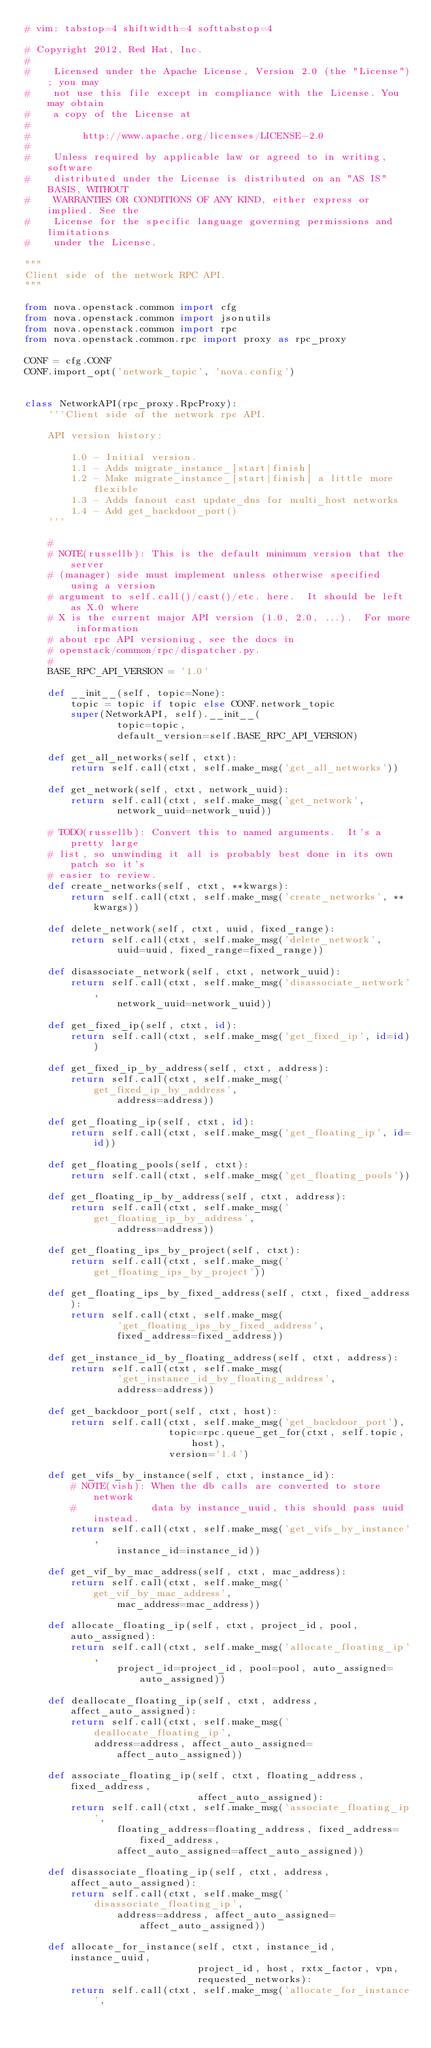Convert code to text. <code><loc_0><loc_0><loc_500><loc_500><_Python_># vim: tabstop=4 shiftwidth=4 softtabstop=4

# Copyright 2012, Red Hat, Inc.
#
#    Licensed under the Apache License, Version 2.0 (the "License"); you may
#    not use this file except in compliance with the License. You may obtain
#    a copy of the License at
#
#         http://www.apache.org/licenses/LICENSE-2.0
#
#    Unless required by applicable law or agreed to in writing, software
#    distributed under the License is distributed on an "AS IS" BASIS, WITHOUT
#    WARRANTIES OR CONDITIONS OF ANY KIND, either express or implied. See the
#    License for the specific language governing permissions and limitations
#    under the License.

"""
Client side of the network RPC API.
"""

from nova.openstack.common import cfg
from nova.openstack.common import jsonutils
from nova.openstack.common import rpc
from nova.openstack.common.rpc import proxy as rpc_proxy

CONF = cfg.CONF
CONF.import_opt('network_topic', 'nova.config')


class NetworkAPI(rpc_proxy.RpcProxy):
    '''Client side of the network rpc API.

    API version history:

        1.0 - Initial version.
        1.1 - Adds migrate_instance_[start|finish]
        1.2 - Make migrate_instance_[start|finish] a little more flexible
        1.3 - Adds fanout cast update_dns for multi_host networks
        1.4 - Add get_backdoor_port()
    '''

    #
    # NOTE(russellb): This is the default minimum version that the server
    # (manager) side must implement unless otherwise specified using a version
    # argument to self.call()/cast()/etc. here.  It should be left as X.0 where
    # X is the current major API version (1.0, 2.0, ...).  For more information
    # about rpc API versioning, see the docs in
    # openstack/common/rpc/dispatcher.py.
    #
    BASE_RPC_API_VERSION = '1.0'

    def __init__(self, topic=None):
        topic = topic if topic else CONF.network_topic
        super(NetworkAPI, self).__init__(
                topic=topic,
                default_version=self.BASE_RPC_API_VERSION)

    def get_all_networks(self, ctxt):
        return self.call(ctxt, self.make_msg('get_all_networks'))

    def get_network(self, ctxt, network_uuid):
        return self.call(ctxt, self.make_msg('get_network',
                network_uuid=network_uuid))

    # TODO(russellb): Convert this to named arguments.  It's a pretty large
    # list, so unwinding it all is probably best done in its own patch so it's
    # easier to review.
    def create_networks(self, ctxt, **kwargs):
        return self.call(ctxt, self.make_msg('create_networks', **kwargs))

    def delete_network(self, ctxt, uuid, fixed_range):
        return self.call(ctxt, self.make_msg('delete_network',
                uuid=uuid, fixed_range=fixed_range))

    def disassociate_network(self, ctxt, network_uuid):
        return self.call(ctxt, self.make_msg('disassociate_network',
                network_uuid=network_uuid))

    def get_fixed_ip(self, ctxt, id):
        return self.call(ctxt, self.make_msg('get_fixed_ip', id=id))

    def get_fixed_ip_by_address(self, ctxt, address):
        return self.call(ctxt, self.make_msg('get_fixed_ip_by_address',
                address=address))

    def get_floating_ip(self, ctxt, id):
        return self.call(ctxt, self.make_msg('get_floating_ip', id=id))

    def get_floating_pools(self, ctxt):
        return self.call(ctxt, self.make_msg('get_floating_pools'))

    def get_floating_ip_by_address(self, ctxt, address):
        return self.call(ctxt, self.make_msg('get_floating_ip_by_address',
                address=address))

    def get_floating_ips_by_project(self, ctxt):
        return self.call(ctxt, self.make_msg('get_floating_ips_by_project'))

    def get_floating_ips_by_fixed_address(self, ctxt, fixed_address):
        return self.call(ctxt, self.make_msg(
                'get_floating_ips_by_fixed_address',
                fixed_address=fixed_address))

    def get_instance_id_by_floating_address(self, ctxt, address):
        return self.call(ctxt, self.make_msg(
                'get_instance_id_by_floating_address',
                address=address))

    def get_backdoor_port(self, ctxt, host):
        return self.call(ctxt, self.make_msg('get_backdoor_port'),
                         topic=rpc.queue_get_for(ctxt, self.topic, host),
                         version='1.4')

    def get_vifs_by_instance(self, ctxt, instance_id):
        # NOTE(vish): When the db calls are converted to store network
        #             data by instance_uuid, this should pass uuid instead.
        return self.call(ctxt, self.make_msg('get_vifs_by_instance',
                instance_id=instance_id))

    def get_vif_by_mac_address(self, ctxt, mac_address):
        return self.call(ctxt, self.make_msg('get_vif_by_mac_address',
                mac_address=mac_address))

    def allocate_floating_ip(self, ctxt, project_id, pool, auto_assigned):
        return self.call(ctxt, self.make_msg('allocate_floating_ip',
                project_id=project_id, pool=pool, auto_assigned=auto_assigned))

    def deallocate_floating_ip(self, ctxt, address, affect_auto_assigned):
        return self.call(ctxt, self.make_msg('deallocate_floating_ip',
            address=address, affect_auto_assigned=affect_auto_assigned))

    def associate_floating_ip(self, ctxt, floating_address, fixed_address,
                              affect_auto_assigned):
        return self.call(ctxt, self.make_msg('associate_floating_ip',
                floating_address=floating_address, fixed_address=fixed_address,
                affect_auto_assigned=affect_auto_assigned))

    def disassociate_floating_ip(self, ctxt, address, affect_auto_assigned):
        return self.call(ctxt, self.make_msg('disassociate_floating_ip',
                address=address, affect_auto_assigned=affect_auto_assigned))

    def allocate_for_instance(self, ctxt, instance_id, instance_uuid,
                              project_id, host, rxtx_factor, vpn,
                              requested_networks):
        return self.call(ctxt, self.make_msg('allocate_for_instance',</code> 